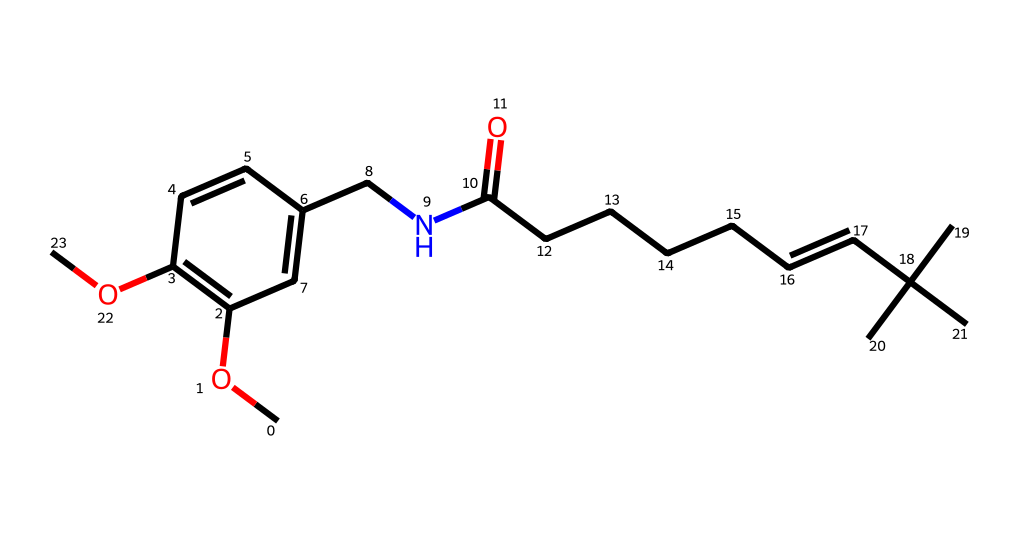What is the primary functional group in capsaicin? The structure shows an amide group (CNC) along with ether (COC) indicating the presence of these functional groups in capsaicin. The key functional group contributing to its spiciness is the amide.
Answer: amide How many carbon atoms are present in capsaicin? By examining the structure, we count a total of 21 carbon atoms in the skeleton of capsaicin as indicated by the numerous C symbols in the SMILES representation.
Answer: 21 What type of bond connects the amide nitrogen to the carbon atoms? The amide nitrogen (N) is connected to the carbon through a single covalent bond, which is characteristic of amide structures where nitrogen is bound to the carbonyl carbon.
Answer: single bond What structural feature is responsible for the pungent taste of capsaicin? The presence of the amide group (CNC) along with the long alkyl chain contributes to capsaicin's pungent taste, which is characteristic of compounds found in chili peppers.
Answer: amide group How many double bonds are present in the capsaicin structure? Investigating the structure reveals one or more double bonds in the aliphatic chain as indicated in the SMILES with the "/C=C/" notation, which clarifies the presence of a double bond in the molecule.
Answer: 1 What is the molecular formula of capsaicin? The entire chemical structure counts 21 carbon, 30 hydrogen, 1 nitrogen, and 3 oxygen atoms, leading to the molecular formula C18H27NO3.
Answer: C18H27NO3 